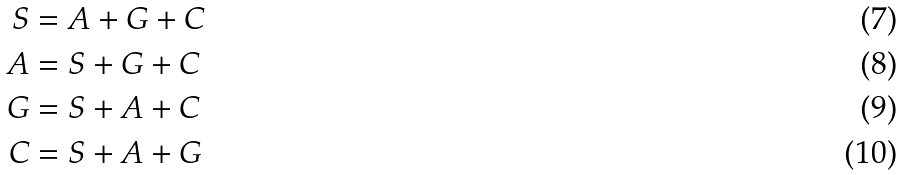Convert formula to latex. <formula><loc_0><loc_0><loc_500><loc_500>S & = A + G + C \\ A & = S + G + C \\ G & = S + A + C \\ C & = S + A + G</formula> 